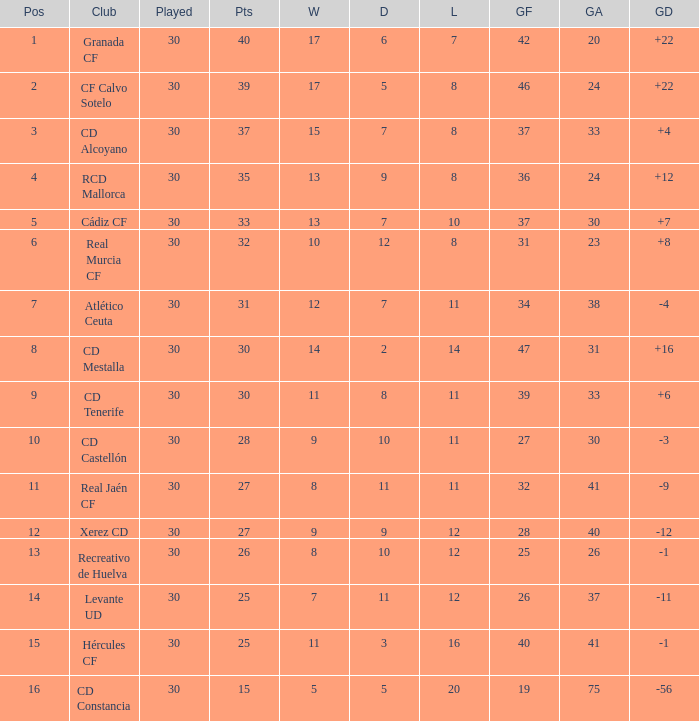How many Draws have 30 Points, and less than 33 Goals against? 1.0. Could you parse the entire table? {'header': ['Pos', 'Club', 'Played', 'Pts', 'W', 'D', 'L', 'GF', 'GA', 'GD'], 'rows': [['1', 'Granada CF', '30', '40', '17', '6', '7', '42', '20', '+22'], ['2', 'CF Calvo Sotelo', '30', '39', '17', '5', '8', '46', '24', '+22'], ['3', 'CD Alcoyano', '30', '37', '15', '7', '8', '37', '33', '+4'], ['4', 'RCD Mallorca', '30', '35', '13', '9', '8', '36', '24', '+12'], ['5', 'Cádiz CF', '30', '33', '13', '7', '10', '37', '30', '+7'], ['6', 'Real Murcia CF', '30', '32', '10', '12', '8', '31', '23', '+8'], ['7', 'Atlético Ceuta', '30', '31', '12', '7', '11', '34', '38', '-4'], ['8', 'CD Mestalla', '30', '30', '14', '2', '14', '47', '31', '+16'], ['9', 'CD Tenerife', '30', '30', '11', '8', '11', '39', '33', '+6'], ['10', 'CD Castellón', '30', '28', '9', '10', '11', '27', '30', '-3'], ['11', 'Real Jaén CF', '30', '27', '8', '11', '11', '32', '41', '-9'], ['12', 'Xerez CD', '30', '27', '9', '9', '12', '28', '40', '-12'], ['13', 'Recreativo de Huelva', '30', '26', '8', '10', '12', '25', '26', '-1'], ['14', 'Levante UD', '30', '25', '7', '11', '12', '26', '37', '-11'], ['15', 'Hércules CF', '30', '25', '11', '3', '16', '40', '41', '-1'], ['16', 'CD Constancia', '30', '15', '5', '5', '20', '19', '75', '-56']]} 